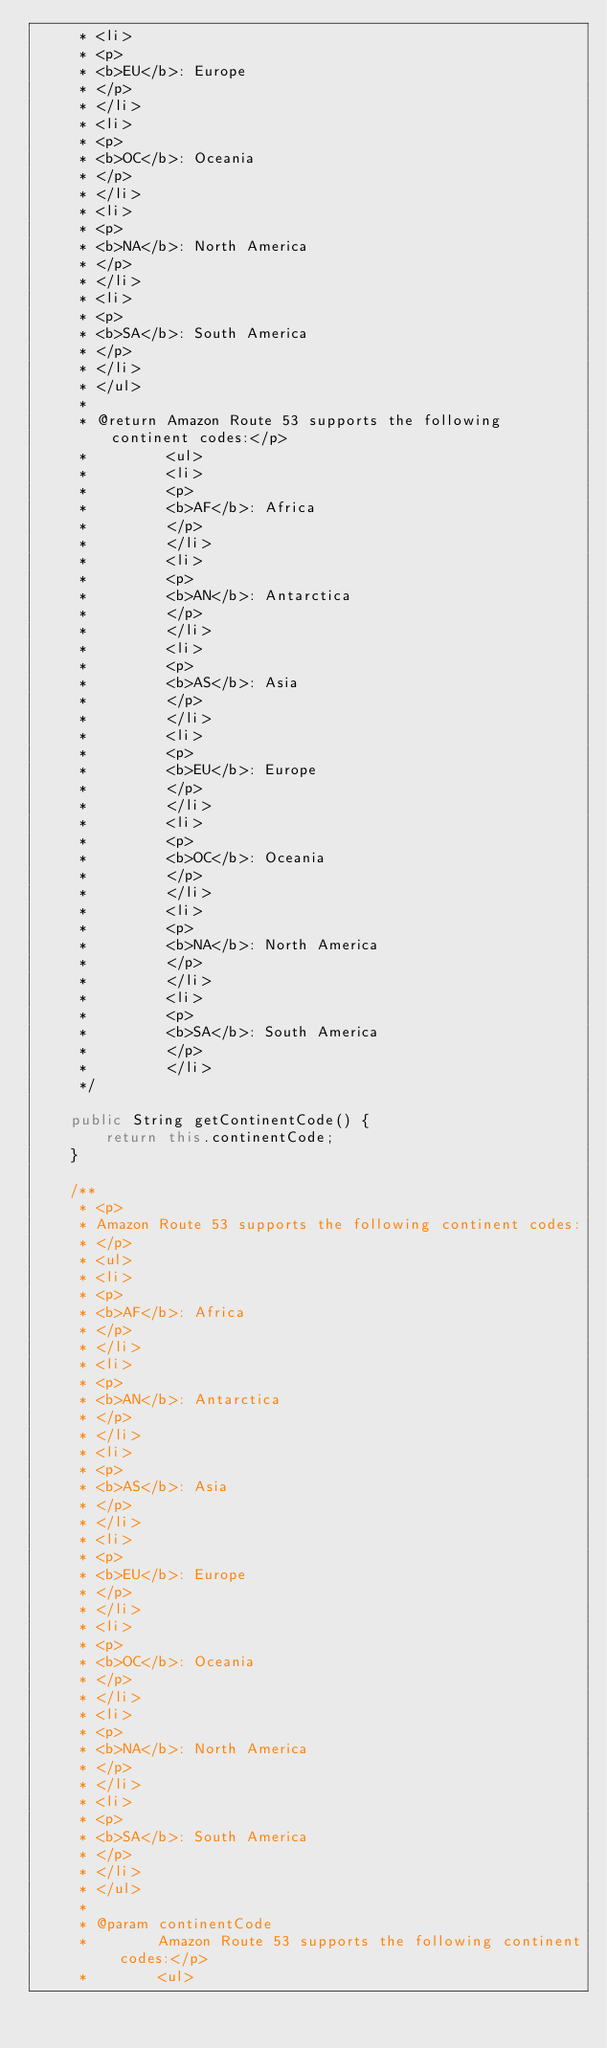Convert code to text. <code><loc_0><loc_0><loc_500><loc_500><_Java_>     * <li>
     * <p>
     * <b>EU</b>: Europe
     * </p>
     * </li>
     * <li>
     * <p>
     * <b>OC</b>: Oceania
     * </p>
     * </li>
     * <li>
     * <p>
     * <b>NA</b>: North America
     * </p>
     * </li>
     * <li>
     * <p>
     * <b>SA</b>: South America
     * </p>
     * </li>
     * </ul>
     * 
     * @return Amazon Route 53 supports the following continent codes:</p>
     *         <ul>
     *         <li>
     *         <p>
     *         <b>AF</b>: Africa
     *         </p>
     *         </li>
     *         <li>
     *         <p>
     *         <b>AN</b>: Antarctica
     *         </p>
     *         </li>
     *         <li>
     *         <p>
     *         <b>AS</b>: Asia
     *         </p>
     *         </li>
     *         <li>
     *         <p>
     *         <b>EU</b>: Europe
     *         </p>
     *         </li>
     *         <li>
     *         <p>
     *         <b>OC</b>: Oceania
     *         </p>
     *         </li>
     *         <li>
     *         <p>
     *         <b>NA</b>: North America
     *         </p>
     *         </li>
     *         <li>
     *         <p>
     *         <b>SA</b>: South America
     *         </p>
     *         </li>
     */

    public String getContinentCode() {
        return this.continentCode;
    }

    /**
     * <p>
     * Amazon Route 53 supports the following continent codes:
     * </p>
     * <ul>
     * <li>
     * <p>
     * <b>AF</b>: Africa
     * </p>
     * </li>
     * <li>
     * <p>
     * <b>AN</b>: Antarctica
     * </p>
     * </li>
     * <li>
     * <p>
     * <b>AS</b>: Asia
     * </p>
     * </li>
     * <li>
     * <p>
     * <b>EU</b>: Europe
     * </p>
     * </li>
     * <li>
     * <p>
     * <b>OC</b>: Oceania
     * </p>
     * </li>
     * <li>
     * <p>
     * <b>NA</b>: North America
     * </p>
     * </li>
     * <li>
     * <p>
     * <b>SA</b>: South America
     * </p>
     * </li>
     * </ul>
     * 
     * @param continentCode
     *        Amazon Route 53 supports the following continent codes:</p>
     *        <ul></code> 